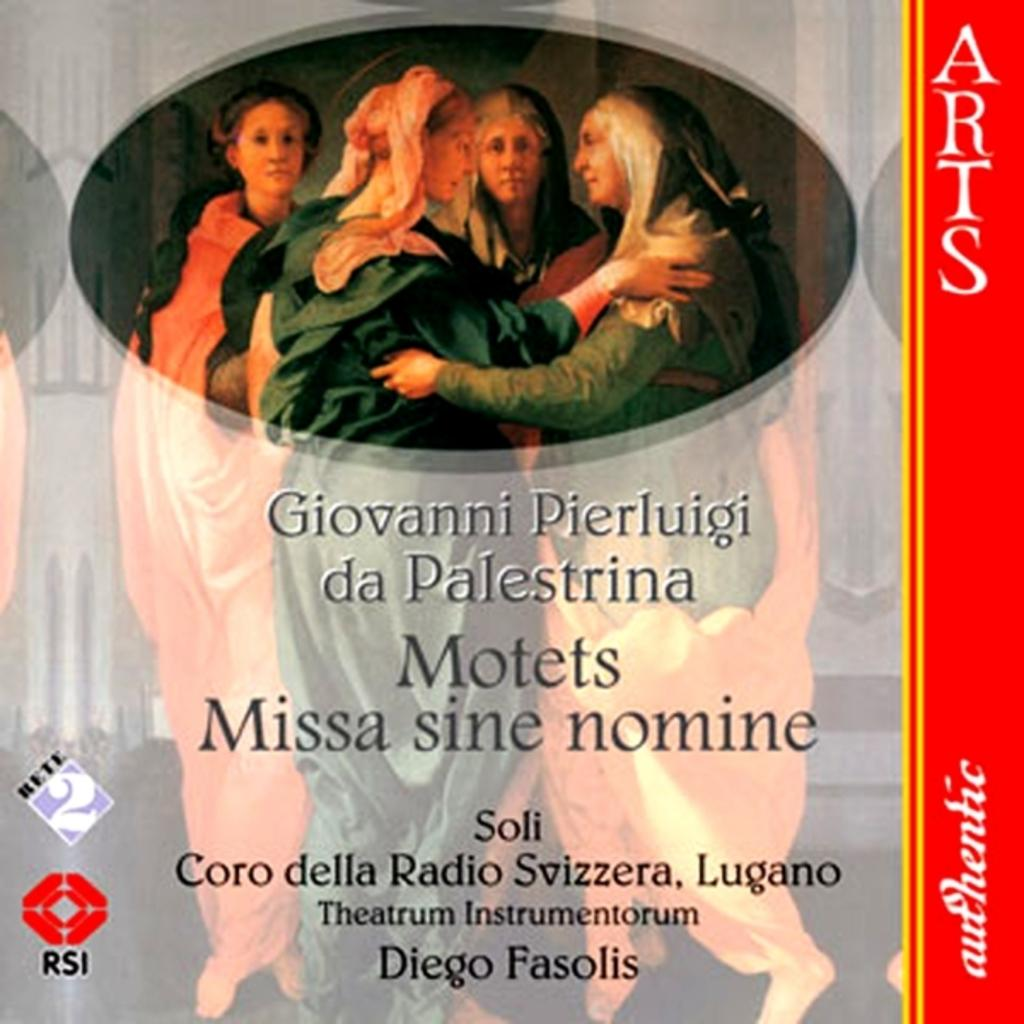<image>
Present a compact description of the photo's key features. An image of what might be a record cover includes the words Motets and Missa sine nomine. 